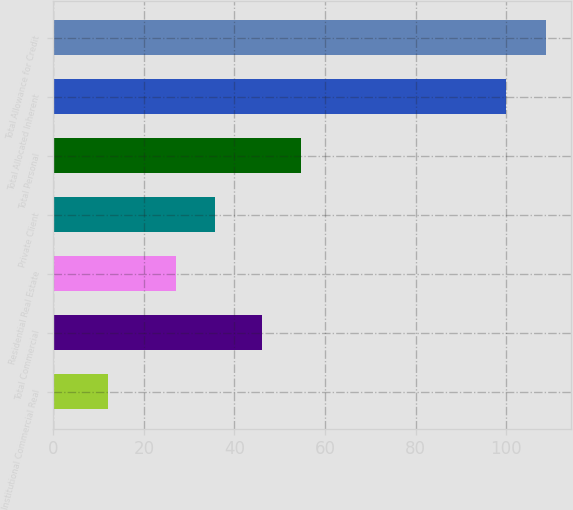Convert chart to OTSL. <chart><loc_0><loc_0><loc_500><loc_500><bar_chart><fcel>Institutional Commercial Real<fcel>Total Commercial<fcel>Residential Real Estate<fcel>Private Client<fcel>Total Personal<fcel>Total Allocated Inherent<fcel>Total Allowance for Credit<nl><fcel>12<fcel>46<fcel>27<fcel>35.8<fcel>54.8<fcel>100<fcel>108.8<nl></chart> 